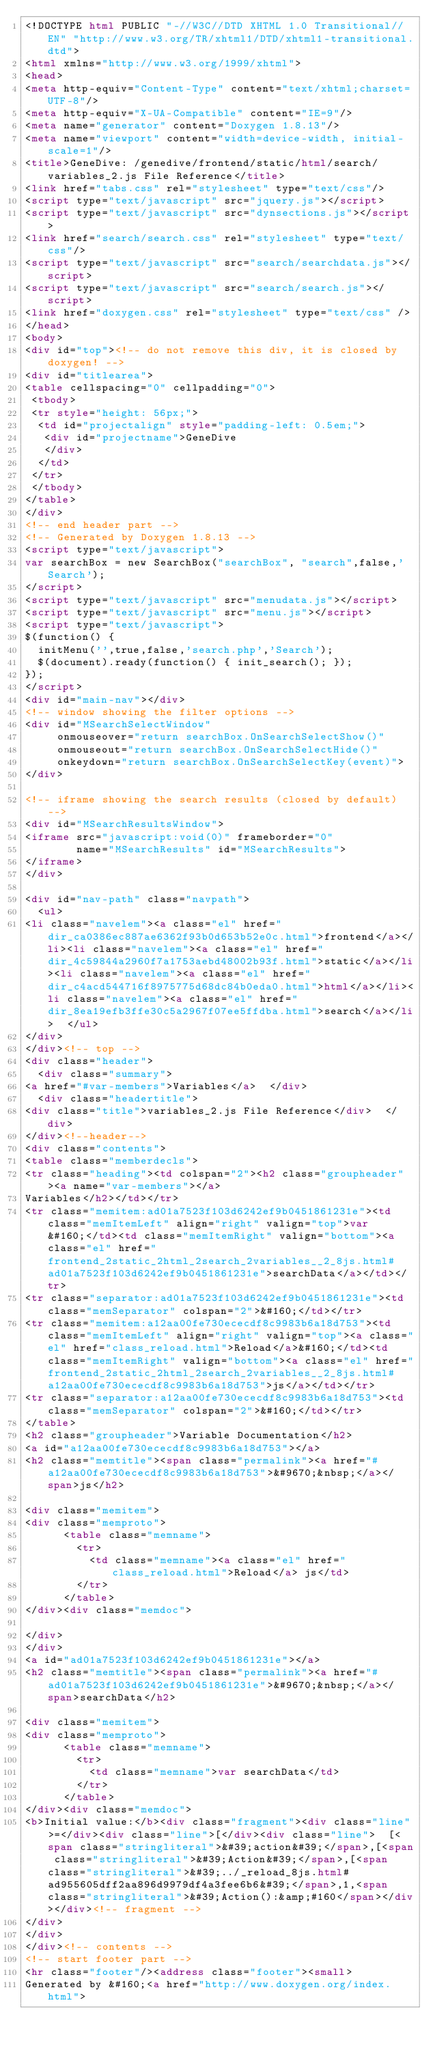<code> <loc_0><loc_0><loc_500><loc_500><_HTML_><!DOCTYPE html PUBLIC "-//W3C//DTD XHTML 1.0 Transitional//EN" "http://www.w3.org/TR/xhtml1/DTD/xhtml1-transitional.dtd">
<html xmlns="http://www.w3.org/1999/xhtml">
<head>
<meta http-equiv="Content-Type" content="text/xhtml;charset=UTF-8"/>
<meta http-equiv="X-UA-Compatible" content="IE=9"/>
<meta name="generator" content="Doxygen 1.8.13"/>
<meta name="viewport" content="width=device-width, initial-scale=1"/>
<title>GeneDive: /genedive/frontend/static/html/search/variables_2.js File Reference</title>
<link href="tabs.css" rel="stylesheet" type="text/css"/>
<script type="text/javascript" src="jquery.js"></script>
<script type="text/javascript" src="dynsections.js"></script>
<link href="search/search.css" rel="stylesheet" type="text/css"/>
<script type="text/javascript" src="search/searchdata.js"></script>
<script type="text/javascript" src="search/search.js"></script>
<link href="doxygen.css" rel="stylesheet" type="text/css" />
</head>
<body>
<div id="top"><!-- do not remove this div, it is closed by doxygen! -->
<div id="titlearea">
<table cellspacing="0" cellpadding="0">
 <tbody>
 <tr style="height: 56px;">
  <td id="projectalign" style="padding-left: 0.5em;">
   <div id="projectname">GeneDive
   </div>
  </td>
 </tr>
 </tbody>
</table>
</div>
<!-- end header part -->
<!-- Generated by Doxygen 1.8.13 -->
<script type="text/javascript">
var searchBox = new SearchBox("searchBox", "search",false,'Search');
</script>
<script type="text/javascript" src="menudata.js"></script>
<script type="text/javascript" src="menu.js"></script>
<script type="text/javascript">
$(function() {
  initMenu('',true,false,'search.php','Search');
  $(document).ready(function() { init_search(); });
});
</script>
<div id="main-nav"></div>
<!-- window showing the filter options -->
<div id="MSearchSelectWindow"
     onmouseover="return searchBox.OnSearchSelectShow()"
     onmouseout="return searchBox.OnSearchSelectHide()"
     onkeydown="return searchBox.OnSearchSelectKey(event)">
</div>

<!-- iframe showing the search results (closed by default) -->
<div id="MSearchResultsWindow">
<iframe src="javascript:void(0)" frameborder="0" 
        name="MSearchResults" id="MSearchResults">
</iframe>
</div>

<div id="nav-path" class="navpath">
  <ul>
<li class="navelem"><a class="el" href="dir_ca0386ec887ae6362f93b0d653b52e0c.html">frontend</a></li><li class="navelem"><a class="el" href="dir_4c59844a2960f7a1753aebd48002b93f.html">static</a></li><li class="navelem"><a class="el" href="dir_c4acd544716f8975775d68dc84b0eda0.html">html</a></li><li class="navelem"><a class="el" href="dir_8ea19efb3ffe30c5a2967f07ee5ffdba.html">search</a></li>  </ul>
</div>
</div><!-- top -->
<div class="header">
  <div class="summary">
<a href="#var-members">Variables</a>  </div>
  <div class="headertitle">
<div class="title">variables_2.js File Reference</div>  </div>
</div><!--header-->
<div class="contents">
<table class="memberdecls">
<tr class="heading"><td colspan="2"><h2 class="groupheader"><a name="var-members"></a>
Variables</h2></td></tr>
<tr class="memitem:ad01a7523f103d6242ef9b0451861231e"><td class="memItemLeft" align="right" valign="top">var&#160;</td><td class="memItemRight" valign="bottom"><a class="el" href="frontend_2static_2html_2search_2variables__2_8js.html#ad01a7523f103d6242ef9b0451861231e">searchData</a></td></tr>
<tr class="separator:ad01a7523f103d6242ef9b0451861231e"><td class="memSeparator" colspan="2">&#160;</td></tr>
<tr class="memitem:a12aa00fe730ececdf8c9983b6a18d753"><td class="memItemLeft" align="right" valign="top"><a class="el" href="class_reload.html">Reload</a>&#160;</td><td class="memItemRight" valign="bottom"><a class="el" href="frontend_2static_2html_2search_2variables__2_8js.html#a12aa00fe730ececdf8c9983b6a18d753">js</a></td></tr>
<tr class="separator:a12aa00fe730ececdf8c9983b6a18d753"><td class="memSeparator" colspan="2">&#160;</td></tr>
</table>
<h2 class="groupheader">Variable Documentation</h2>
<a id="a12aa00fe730ececdf8c9983b6a18d753"></a>
<h2 class="memtitle"><span class="permalink"><a href="#a12aa00fe730ececdf8c9983b6a18d753">&#9670;&nbsp;</a></span>js</h2>

<div class="memitem">
<div class="memproto">
      <table class="memname">
        <tr>
          <td class="memname"><a class="el" href="class_reload.html">Reload</a> js</td>
        </tr>
      </table>
</div><div class="memdoc">

</div>
</div>
<a id="ad01a7523f103d6242ef9b0451861231e"></a>
<h2 class="memtitle"><span class="permalink"><a href="#ad01a7523f103d6242ef9b0451861231e">&#9670;&nbsp;</a></span>searchData</h2>

<div class="memitem">
<div class="memproto">
      <table class="memname">
        <tr>
          <td class="memname">var searchData</td>
        </tr>
      </table>
</div><div class="memdoc">
<b>Initial value:</b><div class="fragment"><div class="line">=</div><div class="line">[</div><div class="line">  [<span class="stringliteral">&#39;action&#39;</span>,[<span class="stringliteral">&#39;Action&#39;</span>,[<span class="stringliteral">&#39;../_reload_8js.html#ad955605dff2aa896d9979df4a3fee6b6&#39;</span>,1,<span class="stringliteral">&#39;Action():&amp;#160</span></div></div><!-- fragment -->
</div>
</div>
</div><!-- contents -->
<!-- start footer part -->
<hr class="footer"/><address class="footer"><small>
Generated by &#160;<a href="http://www.doxygen.org/index.html"></code> 